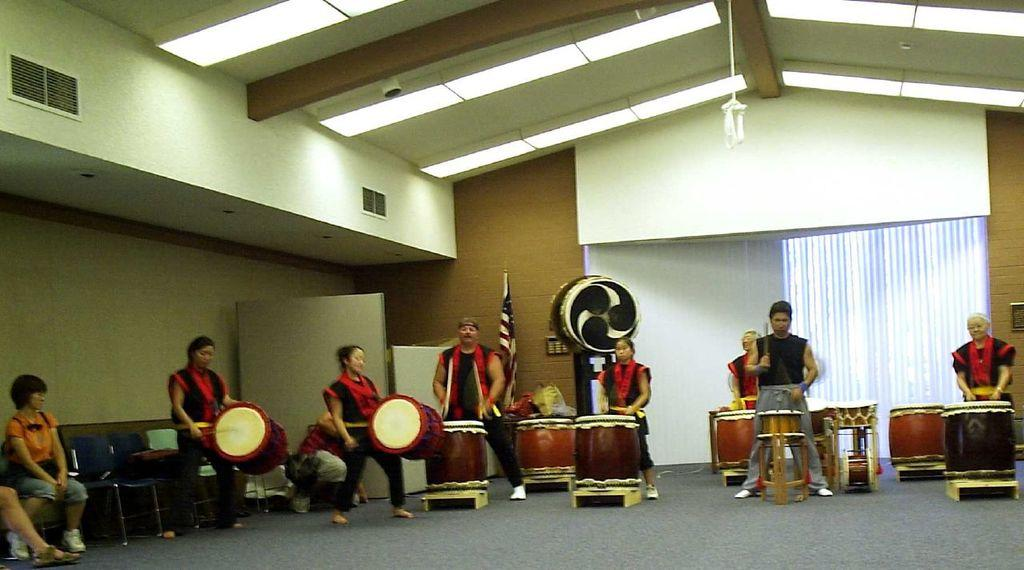What can be seen in the background of the image? There is a wall in the image. What are the people in the image doing? Some people are standing, while others are sitting on chairs in the image. Are there any musical instruments being played in the image? Yes, some people are playing musical drums in the image. What type of pets are visible in the image? There are no pets present in the image. What brand of jeans are the people wearing in the image? The provided facts do not mention any specific clothing items, including jeans. 